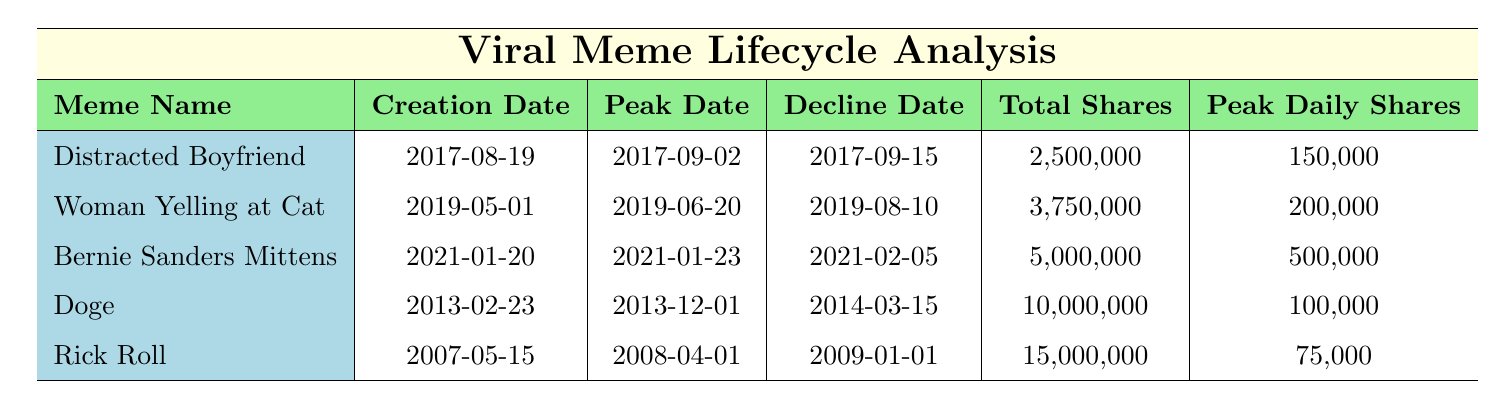What meme reached its peak popularity the fastest? "Bernie Sanders Mittens" peaked in just 3 days after its creation (2021-01-20 to 2021-01-23). The other memes took longer, with the next fastest being "Distracted Boyfriend" at 14 days.
Answer: Bernie Sanders Mittens Which meme had the most total shares? "Rick Roll" had 15,000,000 total shares, making it the meme with the highest shares. Other memes like "Doge" and "Bernie Sanders Mittens" had fewer shares.
Answer: 15,000,000 How many days did it take for "Woman Yelling at Cat" to go from creation to peak popularity? The table lists that "Woman Yelling at Cat" took 50 days to go from its creation date (2019-05-01) to its peak date (2019-06-20).
Answer: 50 days What is the average total shares of the memes listed? The total shares of the 5 memes are: \(2,500,000 + 3,750,000 + 5,000,000 + 10,000,000 + 15,000,000 = 36,250,000\). Dividing this by 5 gives an average of \(36,250,000 / 5 = 7,250,000\).
Answer: 7,250,000 Did all the memes peak on Twitter? No, only "Distracted Boyfriend" and "Bernie Sanders Mittens" peaked on Twitter; "Woman Yelling at Cat" peaked on Instagram, "Doge" peaked on Reddit, and "Rick Roll" peaked on YouTube.
Answer: No What was the peak daily shares for "Doge"? The peak daily shares for "Doge" is listed as 100,000 on the table, which is the maximum number of shares it achieved in a single day.
Answer: 100,000 Which meme had the longest duration from creation to decline? "Rick Roll" had the longest duration from creation to decline, taking a total of 322 days (from 2007-05-15 to 2009-01-01). Other memes had shorter durations.
Answer: Rick Roll What is the total share difference between "Doge" and "Bernie Sanders Mittens"? "Doge" has 10,000,000 shares and "Bernie Sanders Mittens" has 5,000,000 shares. The difference is \(10,000,000 - 5,000,000 = 5,000,000\).
Answer: 5,000,000 How many peak daily shares did "Woman Yelling at Cat" have compared to "Distracted Boyfriend"? "Woman Yelling at Cat" had 200,000 peak daily shares while "Distracted Boyfriend" had 150,000. The difference is \(200,000 - 150,000 = 50,000\) more shares for "Woman Yelling at Cat".
Answer: 50,000 more Which meme creator had the most followers? The creator of "Bernie Sanders Mittens" had the most followers, with a total of 50,000. Compared to the other creators, this was the highest listed.
Answer: 50,000 followers 